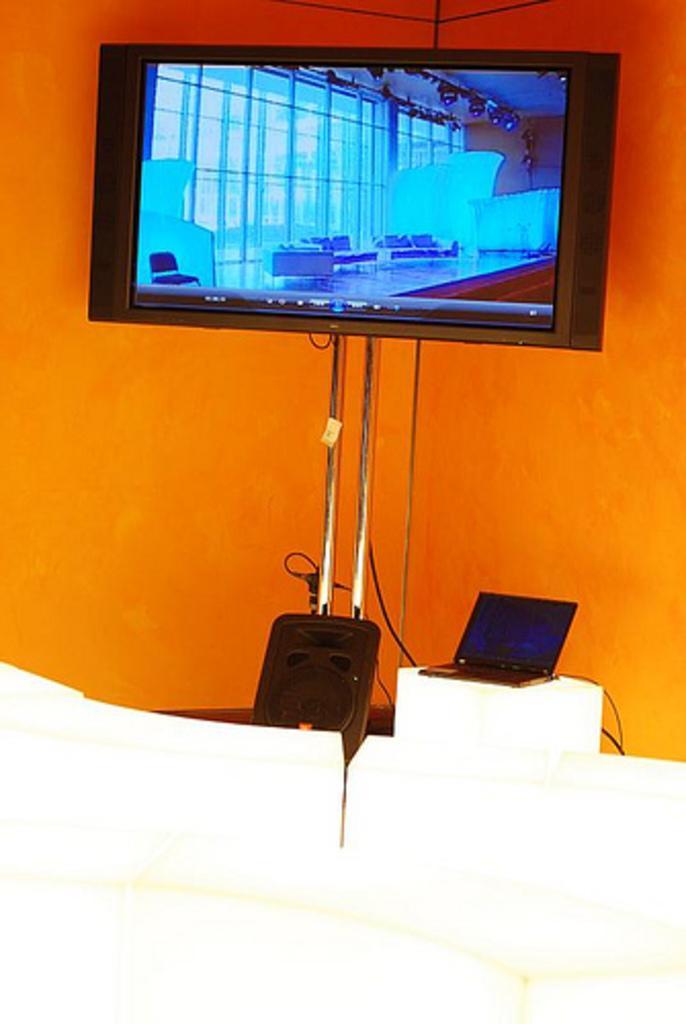Could you give a brief overview of what you see in this image? In this image we can see television included with speakers, stand, laptop and orange wall. 